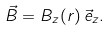Convert formula to latex. <formula><loc_0><loc_0><loc_500><loc_500>\vec { B } = B _ { z } ( r ) \, \vec { e } _ { z } .</formula> 